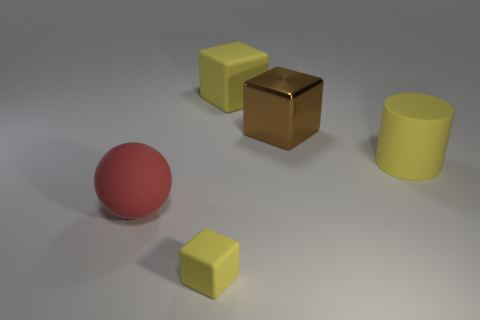Is there a large red object left of the yellow block that is right of the yellow rubber object that is in front of the cylinder?
Your response must be concise. Yes. How many balls are either cyan matte things or big brown objects?
Offer a very short reply. 0. There is a big cube that is right of the large yellow block; what material is it?
Provide a short and direct response. Metal. What size is the cylinder that is the same color as the small rubber thing?
Offer a very short reply. Large. There is a rubber cube behind the small rubber block; does it have the same color as the cube in front of the big cylinder?
Your answer should be very brief. Yes. How many objects are either brown cubes or yellow cylinders?
Offer a terse response. 2. What number of other things are the same shape as the red thing?
Ensure brevity in your answer.  0. Are the big yellow thing that is in front of the large rubber block and the brown cube that is on the right side of the red rubber object made of the same material?
Offer a very short reply. No. There is a thing that is both on the right side of the big matte block and in front of the brown object; what shape is it?
Your response must be concise. Cylinder. Are there any other things that have the same material as the big brown cube?
Provide a succinct answer. No. 